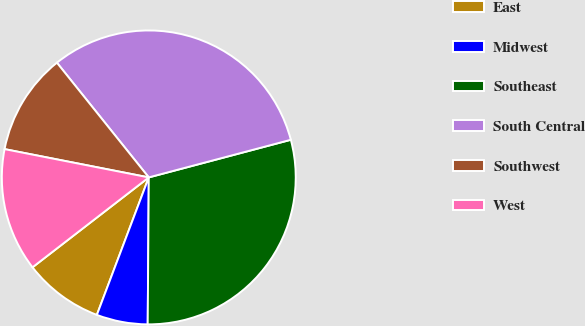Convert chart to OTSL. <chart><loc_0><loc_0><loc_500><loc_500><pie_chart><fcel>East<fcel>Midwest<fcel>Southeast<fcel>South Central<fcel>Southwest<fcel>West<nl><fcel>8.78%<fcel>5.63%<fcel>29.24%<fcel>31.63%<fcel>11.17%<fcel>13.56%<nl></chart> 